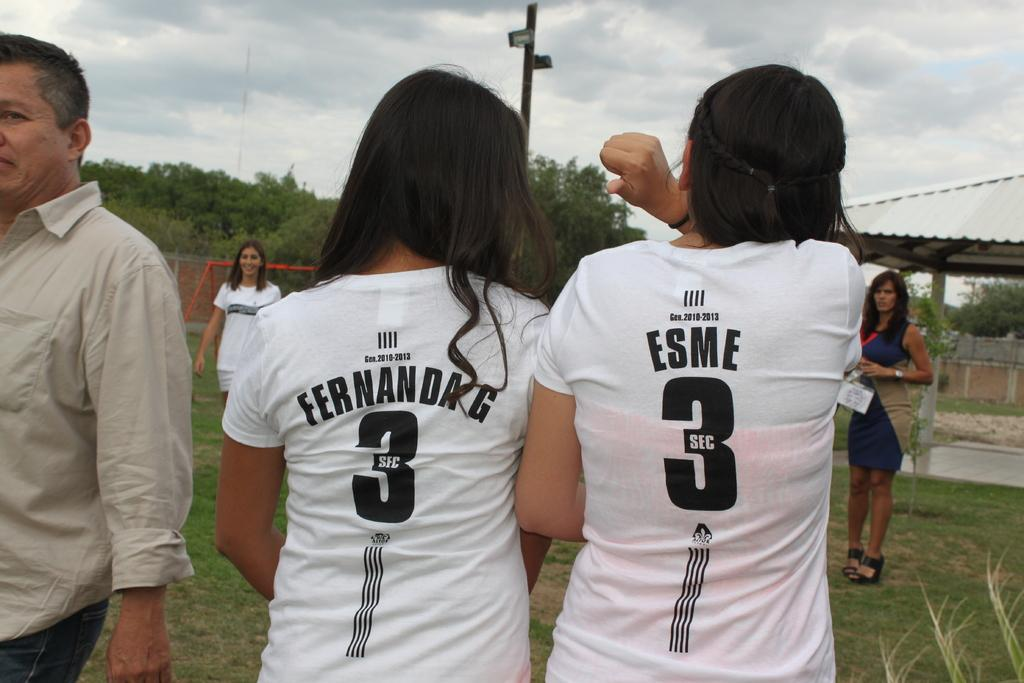Provide a one-sentence caption for the provided image. Player named Fernanda G standing next to another player named Esme. 